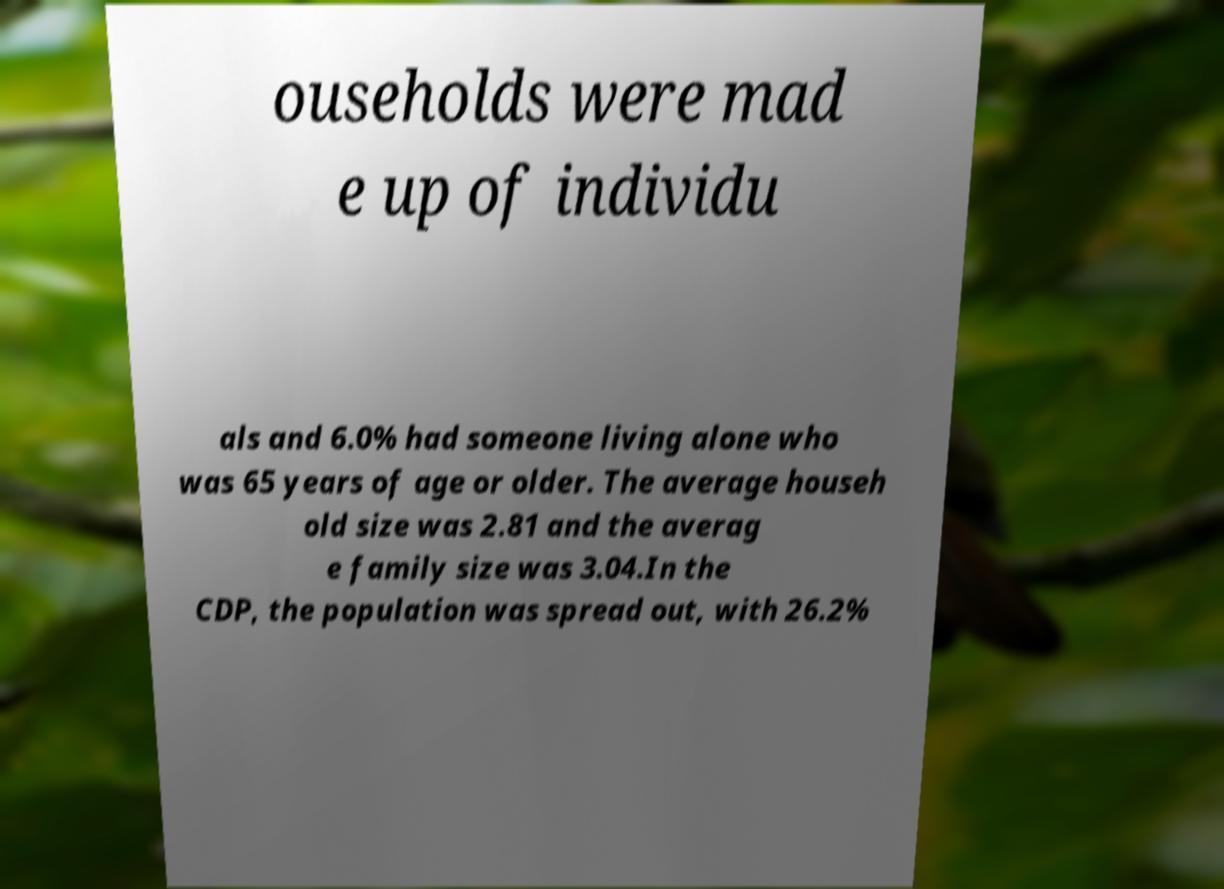Please identify and transcribe the text found in this image. ouseholds were mad e up of individu als and 6.0% had someone living alone who was 65 years of age or older. The average househ old size was 2.81 and the averag e family size was 3.04.In the CDP, the population was spread out, with 26.2% 